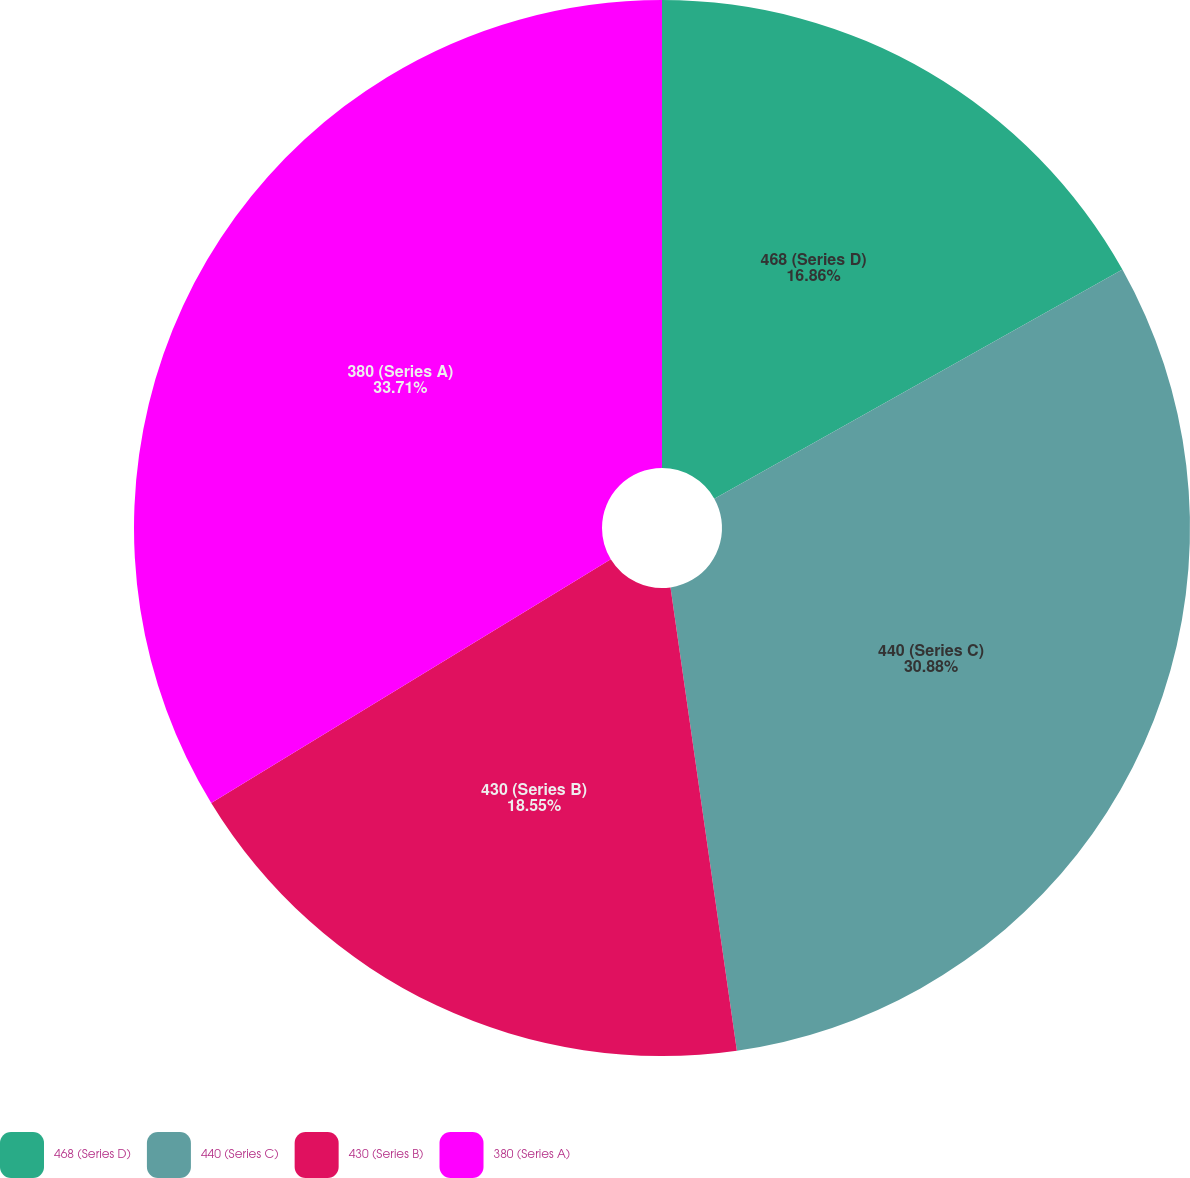Convert chart. <chart><loc_0><loc_0><loc_500><loc_500><pie_chart><fcel>468 (Series D)<fcel>440 (Series C)<fcel>430 (Series B)<fcel>380 (Series A)<nl><fcel>16.86%<fcel>30.88%<fcel>18.55%<fcel>33.72%<nl></chart> 